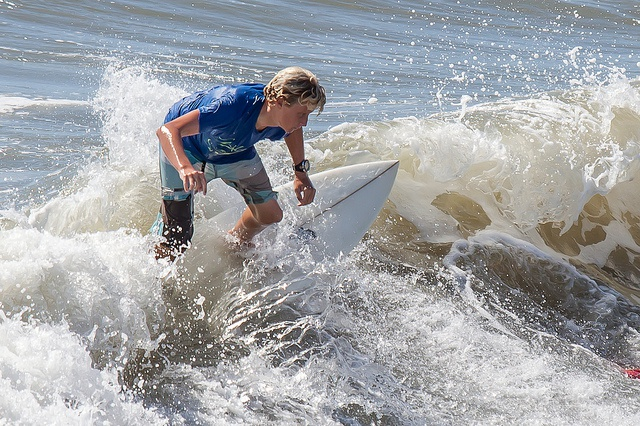Describe the objects in this image and their specific colors. I can see people in white, gray, black, navy, and brown tones and surfboard in white, darkgray, lightgray, and gray tones in this image. 